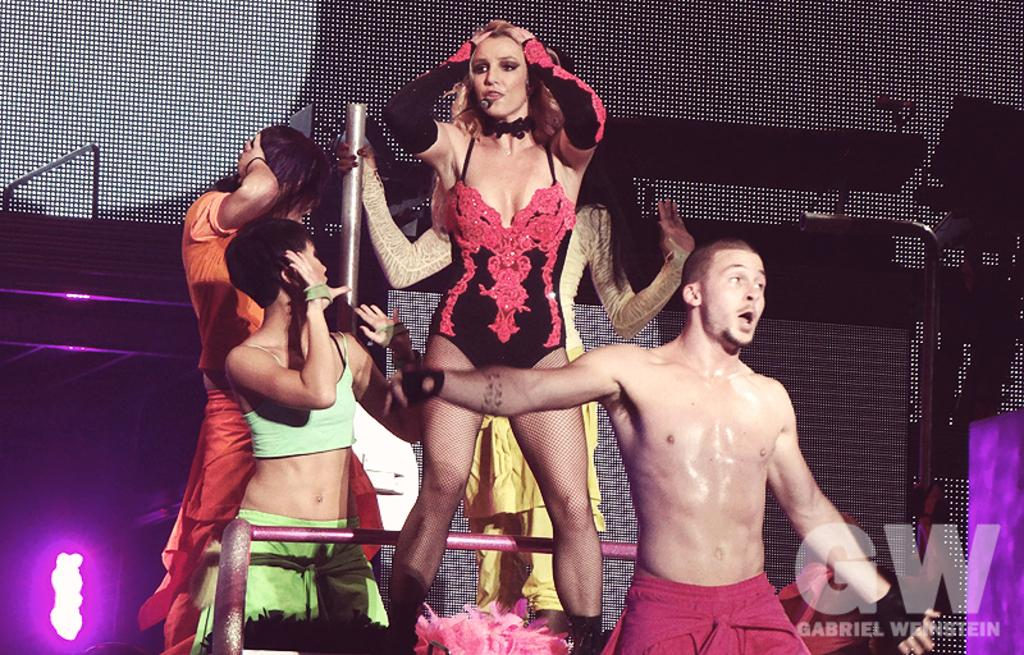What is happening in the foreground of the image? There are people in the foreground of the image. What are the people doing in the image? The people are doing activities. What type of hat is the finger wearing in the image? There is no finger or hat present in the image. 